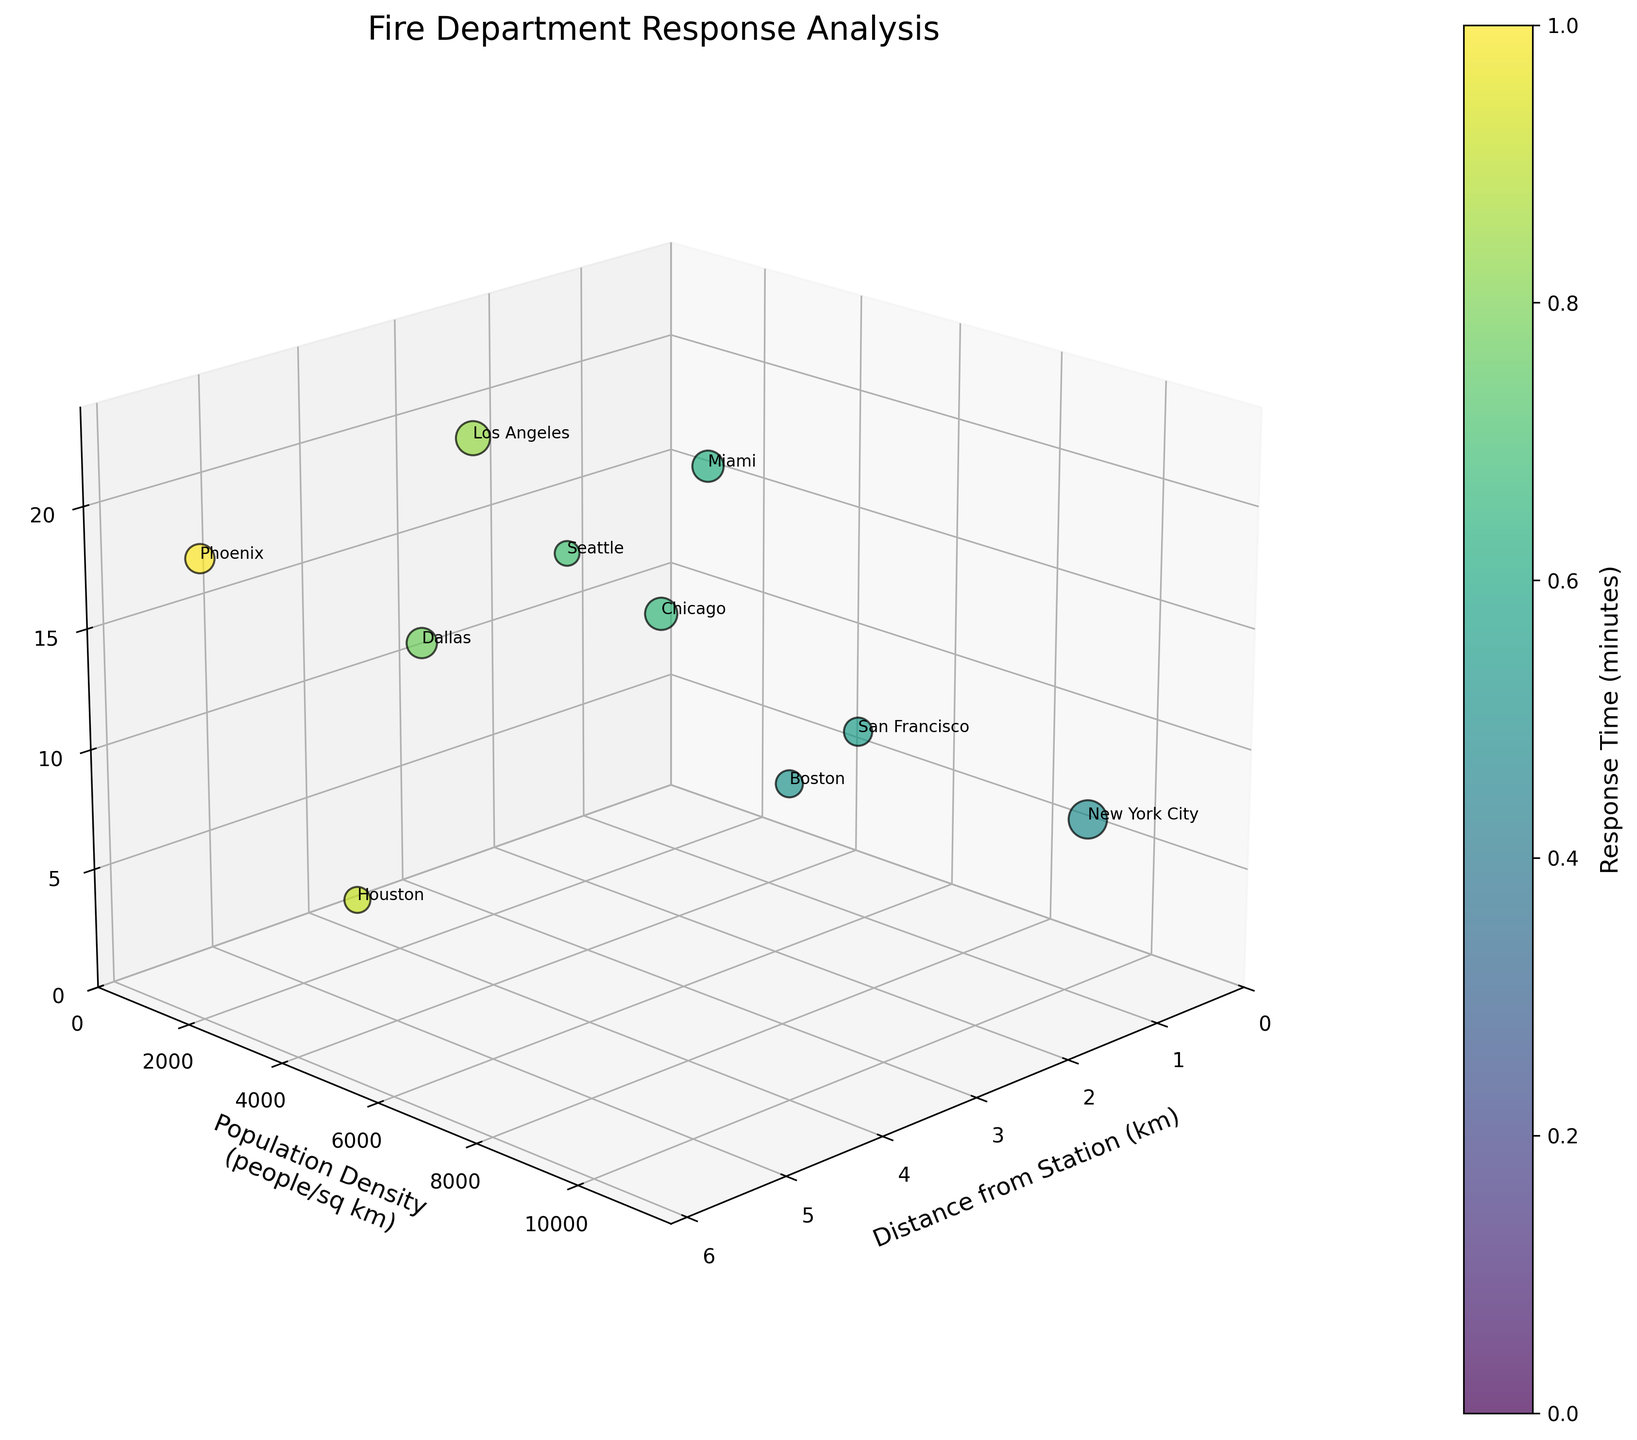What is the title of the chart? The title is located at the top center of the figure and reads "Fire Department Response Analysis."
Answer: Fire Department Response Analysis How many axis labels are there in the figure? The figure contains three axes, each with its own label: the x-axis (Distance from Station (km)), y-axis (Population Density (people/sq km)), and z-axis (Time of Day (hour)).
Answer: Three Which city has the highest population density? By observing the y-axis (Population Density) and identifying the highest point corresponding to the labeled city, we see that New York City has the highest population density of 10,716 people/sq km.
Answer: New York City What is the color bar representing? The color bar, usually found adjacent to the plot, represents 'Response Time (minutes).' The variation in colors across the data points corresponds to different response times.
Answer: Response Time (minutes) How does the response time change as the distance from the station increases? Observing the gradient of colors along the x-axis (Distance from Station), it can be seen that the response time increases as the distance from the station increases. Darker colors indicating higher response times are associated with points farther from the station.
Answer: Increases Compare the response times between New York City and Houston. Which city has a quicker response time and by how much? New York City's response time is 4.5 minutes and Houston's is 8.5 minutes. The difference in response time is calculated by subtracting the smaller time from the larger: 
8.5 - 4.5 = 4.0.
Answer: New York City by 4.0 minutes Which city has the largest bubble size and what does it represent? The largest bubble, judged by size, corresponds to New York City. Bubble size represents the Number of Incidents, and New York City has the most incidents (120).
Answer: New York City, Number of Incidents At what time of day does Los Angeles experience incidents? By locating Los Angeles on the z-axis, which reflects the time of day (hours), it can be determined that the incidents occur at 22:00 (10 PM).
Answer: 22:00 Can you identify any general trend between population density and response time? By examining the distribution of colors with respect to the y-axis (Population Density), cities with higher population densities tend to have quicker response times as indicated by lighter colors.
Answer: Higher population density typically has quicker response times Which city has the highest response time and at what time of day? By finding the city corresponding to the darkest color on the chart and checking its z-axis value, Phoenix has the highest response time of 9.3 minutes at 18:00 (6 PM).
Answer: Phoenix, 18:00 